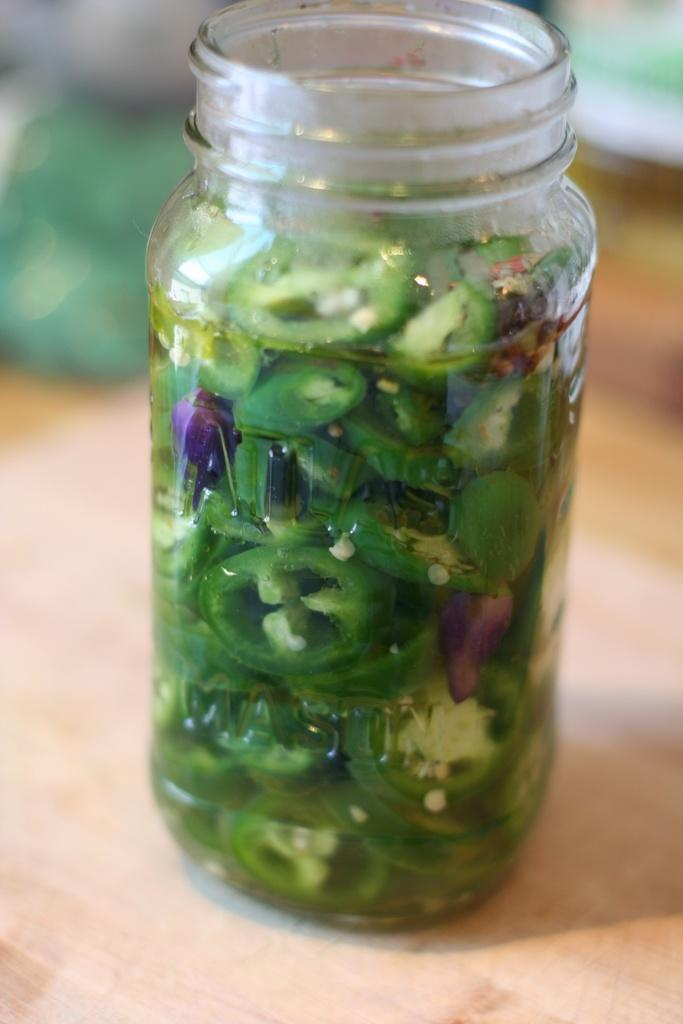What is inside the glass jar in the image? There are capsicum slices in a glass jar. Where is the glass jar located? The glass jar is placed on a wooden surface. What type of stone arch can be seen in the image? There is no stone arch present in the image; it only features a glass jar with capsicum slices and a wooden surface. 